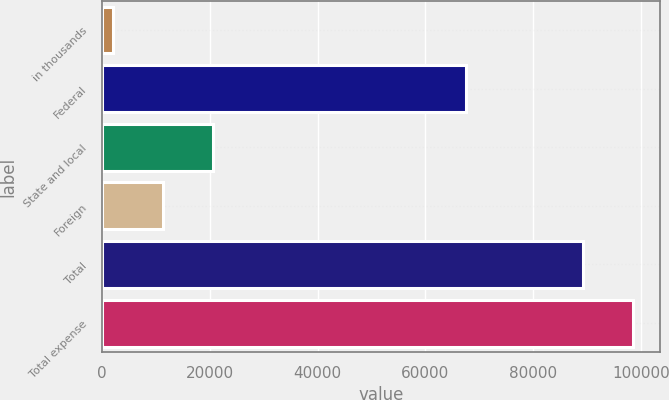<chart> <loc_0><loc_0><loc_500><loc_500><bar_chart><fcel>in thousands<fcel>Federal<fcel>State and local<fcel>Foreign<fcel>Total<fcel>Total expense<nl><fcel>2015<fcel>67521<fcel>20600.6<fcel>11307.8<fcel>89340<fcel>98632.8<nl></chart> 